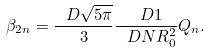Convert formula to latex. <formula><loc_0><loc_0><loc_500><loc_500>\beta _ { 2 n } = \frac { \ D \sqrt { 5 \pi } } { 3 } \frac { \ D 1 } { \ D N R ^ { 2 } _ { 0 } } Q _ { n } .</formula> 